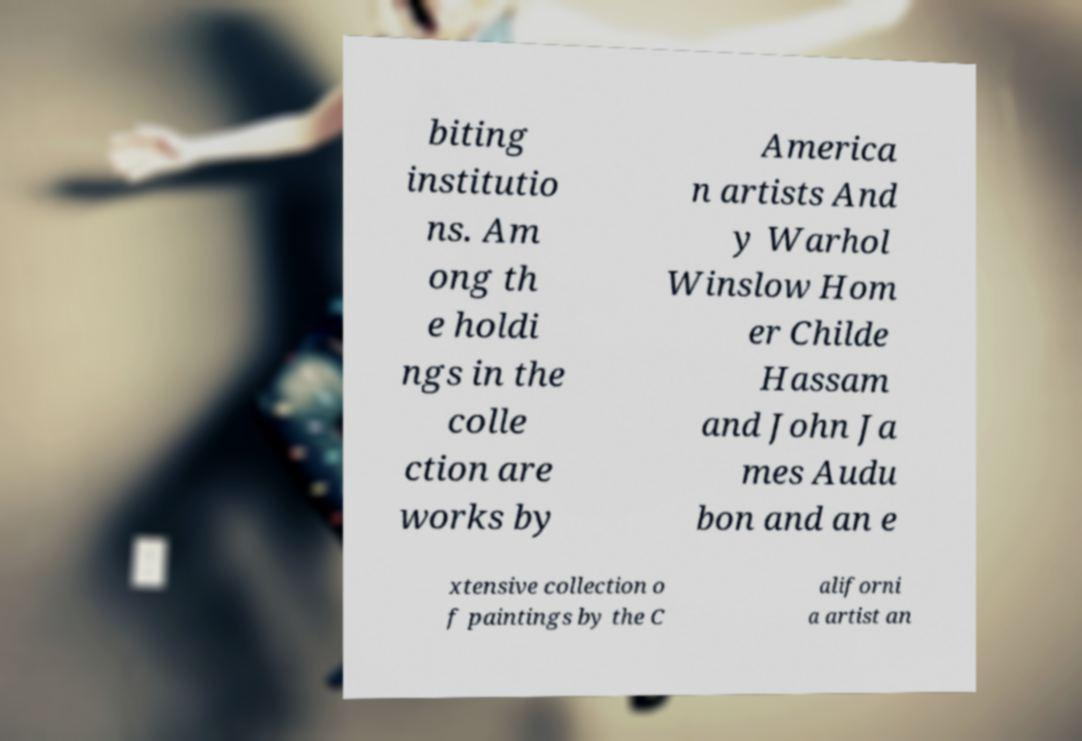Could you assist in decoding the text presented in this image and type it out clearly? biting institutio ns. Am ong th e holdi ngs in the colle ction are works by America n artists And y Warhol Winslow Hom er Childe Hassam and John Ja mes Audu bon and an e xtensive collection o f paintings by the C aliforni a artist an 